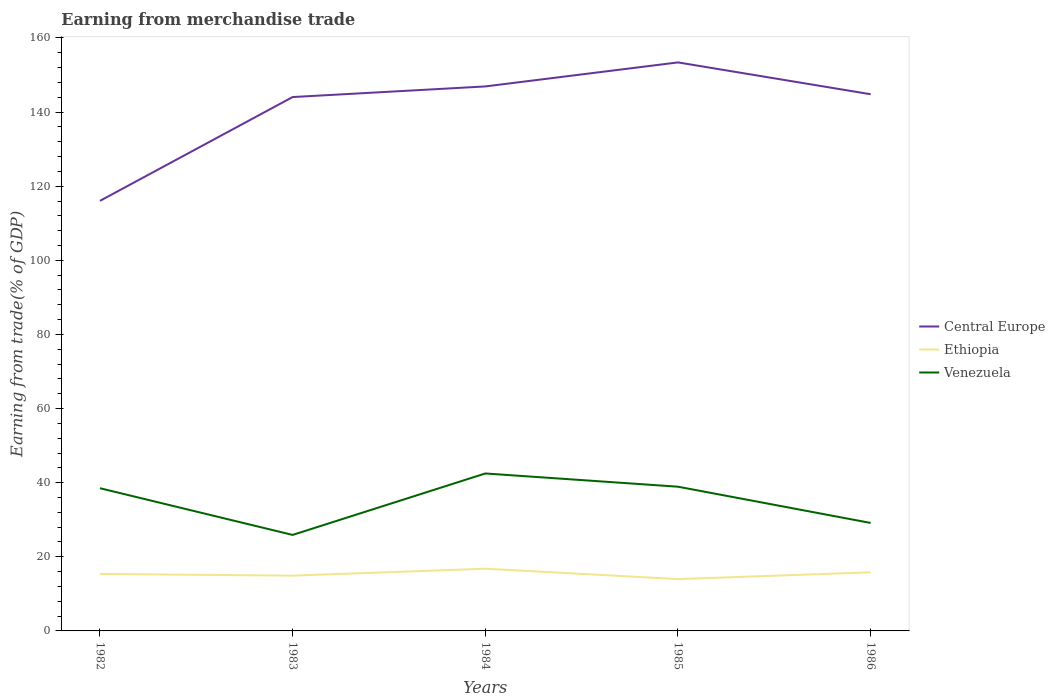How many different coloured lines are there?
Offer a terse response. 3. Does the line corresponding to Venezuela intersect with the line corresponding to Central Europe?
Make the answer very short. No. Is the number of lines equal to the number of legend labels?
Ensure brevity in your answer.  Yes. Across all years, what is the maximum earnings from trade in Central Europe?
Your answer should be very brief. 116.04. What is the total earnings from trade in Venezuela in the graph?
Offer a terse response. 3.57. What is the difference between the highest and the second highest earnings from trade in Venezuela?
Your response must be concise. 16.58. Is the earnings from trade in Ethiopia strictly greater than the earnings from trade in Central Europe over the years?
Give a very brief answer. Yes. Are the values on the major ticks of Y-axis written in scientific E-notation?
Your answer should be very brief. No. How many legend labels are there?
Keep it short and to the point. 3. What is the title of the graph?
Your answer should be compact. Earning from merchandise trade. What is the label or title of the Y-axis?
Give a very brief answer. Earning from trade(% of GDP). What is the Earning from trade(% of GDP) in Central Europe in 1982?
Make the answer very short. 116.04. What is the Earning from trade(% of GDP) in Ethiopia in 1982?
Offer a very short reply. 15.37. What is the Earning from trade(% of GDP) in Venezuela in 1982?
Provide a succinct answer. 38.51. What is the Earning from trade(% of GDP) of Central Europe in 1983?
Offer a terse response. 144.05. What is the Earning from trade(% of GDP) in Ethiopia in 1983?
Provide a short and direct response. 14.92. What is the Earning from trade(% of GDP) in Venezuela in 1983?
Offer a very short reply. 25.9. What is the Earning from trade(% of GDP) of Central Europe in 1984?
Keep it short and to the point. 146.92. What is the Earning from trade(% of GDP) in Ethiopia in 1984?
Your answer should be compact. 16.79. What is the Earning from trade(% of GDP) of Venezuela in 1984?
Give a very brief answer. 42.48. What is the Earning from trade(% of GDP) of Central Europe in 1985?
Ensure brevity in your answer.  153.4. What is the Earning from trade(% of GDP) of Ethiopia in 1985?
Ensure brevity in your answer.  13.99. What is the Earning from trade(% of GDP) in Venezuela in 1985?
Your answer should be very brief. 38.91. What is the Earning from trade(% of GDP) in Central Europe in 1986?
Your response must be concise. 144.81. What is the Earning from trade(% of GDP) in Ethiopia in 1986?
Your response must be concise. 15.81. What is the Earning from trade(% of GDP) in Venezuela in 1986?
Give a very brief answer. 29.13. Across all years, what is the maximum Earning from trade(% of GDP) in Central Europe?
Provide a succinct answer. 153.4. Across all years, what is the maximum Earning from trade(% of GDP) in Ethiopia?
Your answer should be compact. 16.79. Across all years, what is the maximum Earning from trade(% of GDP) of Venezuela?
Ensure brevity in your answer.  42.48. Across all years, what is the minimum Earning from trade(% of GDP) of Central Europe?
Make the answer very short. 116.04. Across all years, what is the minimum Earning from trade(% of GDP) in Ethiopia?
Your answer should be compact. 13.99. Across all years, what is the minimum Earning from trade(% of GDP) of Venezuela?
Make the answer very short. 25.9. What is the total Earning from trade(% of GDP) of Central Europe in the graph?
Offer a terse response. 705.21. What is the total Earning from trade(% of GDP) in Ethiopia in the graph?
Provide a short and direct response. 76.87. What is the total Earning from trade(% of GDP) in Venezuela in the graph?
Your answer should be very brief. 174.94. What is the difference between the Earning from trade(% of GDP) of Central Europe in 1982 and that in 1983?
Provide a succinct answer. -28.01. What is the difference between the Earning from trade(% of GDP) of Ethiopia in 1982 and that in 1983?
Give a very brief answer. 0.46. What is the difference between the Earning from trade(% of GDP) of Venezuela in 1982 and that in 1983?
Provide a succinct answer. 12.61. What is the difference between the Earning from trade(% of GDP) of Central Europe in 1982 and that in 1984?
Your answer should be very brief. -30.88. What is the difference between the Earning from trade(% of GDP) of Ethiopia in 1982 and that in 1984?
Offer a terse response. -1.41. What is the difference between the Earning from trade(% of GDP) in Venezuela in 1982 and that in 1984?
Provide a short and direct response. -3.98. What is the difference between the Earning from trade(% of GDP) in Central Europe in 1982 and that in 1985?
Ensure brevity in your answer.  -37.36. What is the difference between the Earning from trade(% of GDP) of Ethiopia in 1982 and that in 1985?
Offer a terse response. 1.39. What is the difference between the Earning from trade(% of GDP) of Venezuela in 1982 and that in 1985?
Offer a very short reply. -0.4. What is the difference between the Earning from trade(% of GDP) of Central Europe in 1982 and that in 1986?
Give a very brief answer. -28.77. What is the difference between the Earning from trade(% of GDP) of Ethiopia in 1982 and that in 1986?
Keep it short and to the point. -0.44. What is the difference between the Earning from trade(% of GDP) in Venezuela in 1982 and that in 1986?
Provide a succinct answer. 9.38. What is the difference between the Earning from trade(% of GDP) in Central Europe in 1983 and that in 1984?
Your answer should be compact. -2.87. What is the difference between the Earning from trade(% of GDP) of Ethiopia in 1983 and that in 1984?
Your answer should be very brief. -1.87. What is the difference between the Earning from trade(% of GDP) in Venezuela in 1983 and that in 1984?
Offer a terse response. -16.58. What is the difference between the Earning from trade(% of GDP) of Central Europe in 1983 and that in 1985?
Ensure brevity in your answer.  -9.35. What is the difference between the Earning from trade(% of GDP) of Ethiopia in 1983 and that in 1985?
Offer a terse response. 0.93. What is the difference between the Earning from trade(% of GDP) of Venezuela in 1983 and that in 1985?
Your answer should be compact. -13.01. What is the difference between the Earning from trade(% of GDP) of Central Europe in 1983 and that in 1986?
Provide a short and direct response. -0.76. What is the difference between the Earning from trade(% of GDP) in Ethiopia in 1983 and that in 1986?
Ensure brevity in your answer.  -0.89. What is the difference between the Earning from trade(% of GDP) in Venezuela in 1983 and that in 1986?
Ensure brevity in your answer.  -3.23. What is the difference between the Earning from trade(% of GDP) in Central Europe in 1984 and that in 1985?
Ensure brevity in your answer.  -6.48. What is the difference between the Earning from trade(% of GDP) of Ethiopia in 1984 and that in 1985?
Provide a short and direct response. 2.8. What is the difference between the Earning from trade(% of GDP) in Venezuela in 1984 and that in 1985?
Your answer should be compact. 3.57. What is the difference between the Earning from trade(% of GDP) of Central Europe in 1984 and that in 1986?
Give a very brief answer. 2.11. What is the difference between the Earning from trade(% of GDP) of Ethiopia in 1984 and that in 1986?
Your response must be concise. 0.98. What is the difference between the Earning from trade(% of GDP) of Venezuela in 1984 and that in 1986?
Offer a very short reply. 13.35. What is the difference between the Earning from trade(% of GDP) of Central Europe in 1985 and that in 1986?
Make the answer very short. 8.59. What is the difference between the Earning from trade(% of GDP) in Ethiopia in 1985 and that in 1986?
Provide a short and direct response. -1.82. What is the difference between the Earning from trade(% of GDP) of Venezuela in 1985 and that in 1986?
Your answer should be very brief. 9.78. What is the difference between the Earning from trade(% of GDP) of Central Europe in 1982 and the Earning from trade(% of GDP) of Ethiopia in 1983?
Ensure brevity in your answer.  101.12. What is the difference between the Earning from trade(% of GDP) in Central Europe in 1982 and the Earning from trade(% of GDP) in Venezuela in 1983?
Provide a succinct answer. 90.13. What is the difference between the Earning from trade(% of GDP) in Ethiopia in 1982 and the Earning from trade(% of GDP) in Venezuela in 1983?
Provide a succinct answer. -10.53. What is the difference between the Earning from trade(% of GDP) of Central Europe in 1982 and the Earning from trade(% of GDP) of Ethiopia in 1984?
Make the answer very short. 99.25. What is the difference between the Earning from trade(% of GDP) of Central Europe in 1982 and the Earning from trade(% of GDP) of Venezuela in 1984?
Make the answer very short. 73.55. What is the difference between the Earning from trade(% of GDP) in Ethiopia in 1982 and the Earning from trade(% of GDP) in Venezuela in 1984?
Provide a succinct answer. -27.11. What is the difference between the Earning from trade(% of GDP) in Central Europe in 1982 and the Earning from trade(% of GDP) in Ethiopia in 1985?
Provide a succinct answer. 102.05. What is the difference between the Earning from trade(% of GDP) in Central Europe in 1982 and the Earning from trade(% of GDP) in Venezuela in 1985?
Provide a short and direct response. 77.12. What is the difference between the Earning from trade(% of GDP) in Ethiopia in 1982 and the Earning from trade(% of GDP) in Venezuela in 1985?
Offer a very short reply. -23.54. What is the difference between the Earning from trade(% of GDP) of Central Europe in 1982 and the Earning from trade(% of GDP) of Ethiopia in 1986?
Give a very brief answer. 100.23. What is the difference between the Earning from trade(% of GDP) of Central Europe in 1982 and the Earning from trade(% of GDP) of Venezuela in 1986?
Provide a succinct answer. 86.9. What is the difference between the Earning from trade(% of GDP) in Ethiopia in 1982 and the Earning from trade(% of GDP) in Venezuela in 1986?
Offer a very short reply. -13.76. What is the difference between the Earning from trade(% of GDP) of Central Europe in 1983 and the Earning from trade(% of GDP) of Ethiopia in 1984?
Provide a short and direct response. 127.26. What is the difference between the Earning from trade(% of GDP) in Central Europe in 1983 and the Earning from trade(% of GDP) in Venezuela in 1984?
Provide a short and direct response. 101.57. What is the difference between the Earning from trade(% of GDP) in Ethiopia in 1983 and the Earning from trade(% of GDP) in Venezuela in 1984?
Your answer should be compact. -27.57. What is the difference between the Earning from trade(% of GDP) in Central Europe in 1983 and the Earning from trade(% of GDP) in Ethiopia in 1985?
Your response must be concise. 130.06. What is the difference between the Earning from trade(% of GDP) of Central Europe in 1983 and the Earning from trade(% of GDP) of Venezuela in 1985?
Provide a short and direct response. 105.14. What is the difference between the Earning from trade(% of GDP) of Ethiopia in 1983 and the Earning from trade(% of GDP) of Venezuela in 1985?
Provide a short and direct response. -24. What is the difference between the Earning from trade(% of GDP) of Central Europe in 1983 and the Earning from trade(% of GDP) of Ethiopia in 1986?
Offer a very short reply. 128.24. What is the difference between the Earning from trade(% of GDP) of Central Europe in 1983 and the Earning from trade(% of GDP) of Venezuela in 1986?
Provide a short and direct response. 114.92. What is the difference between the Earning from trade(% of GDP) of Ethiopia in 1983 and the Earning from trade(% of GDP) of Venezuela in 1986?
Your answer should be compact. -14.22. What is the difference between the Earning from trade(% of GDP) of Central Europe in 1984 and the Earning from trade(% of GDP) of Ethiopia in 1985?
Ensure brevity in your answer.  132.93. What is the difference between the Earning from trade(% of GDP) of Central Europe in 1984 and the Earning from trade(% of GDP) of Venezuela in 1985?
Give a very brief answer. 108.01. What is the difference between the Earning from trade(% of GDP) in Ethiopia in 1984 and the Earning from trade(% of GDP) in Venezuela in 1985?
Your answer should be very brief. -22.13. What is the difference between the Earning from trade(% of GDP) of Central Europe in 1984 and the Earning from trade(% of GDP) of Ethiopia in 1986?
Your answer should be compact. 131.11. What is the difference between the Earning from trade(% of GDP) in Central Europe in 1984 and the Earning from trade(% of GDP) in Venezuela in 1986?
Keep it short and to the point. 117.78. What is the difference between the Earning from trade(% of GDP) of Ethiopia in 1984 and the Earning from trade(% of GDP) of Venezuela in 1986?
Provide a short and direct response. -12.35. What is the difference between the Earning from trade(% of GDP) of Central Europe in 1985 and the Earning from trade(% of GDP) of Ethiopia in 1986?
Your response must be concise. 137.59. What is the difference between the Earning from trade(% of GDP) in Central Europe in 1985 and the Earning from trade(% of GDP) in Venezuela in 1986?
Your answer should be compact. 124.26. What is the difference between the Earning from trade(% of GDP) of Ethiopia in 1985 and the Earning from trade(% of GDP) of Venezuela in 1986?
Give a very brief answer. -15.15. What is the average Earning from trade(% of GDP) of Central Europe per year?
Provide a succinct answer. 141.04. What is the average Earning from trade(% of GDP) in Ethiopia per year?
Your answer should be compact. 15.37. What is the average Earning from trade(% of GDP) in Venezuela per year?
Your answer should be very brief. 34.99. In the year 1982, what is the difference between the Earning from trade(% of GDP) of Central Europe and Earning from trade(% of GDP) of Ethiopia?
Offer a terse response. 100.66. In the year 1982, what is the difference between the Earning from trade(% of GDP) of Central Europe and Earning from trade(% of GDP) of Venezuela?
Your response must be concise. 77.53. In the year 1982, what is the difference between the Earning from trade(% of GDP) in Ethiopia and Earning from trade(% of GDP) in Venezuela?
Ensure brevity in your answer.  -23.13. In the year 1983, what is the difference between the Earning from trade(% of GDP) of Central Europe and Earning from trade(% of GDP) of Ethiopia?
Your answer should be compact. 129.13. In the year 1983, what is the difference between the Earning from trade(% of GDP) in Central Europe and Earning from trade(% of GDP) in Venezuela?
Offer a very short reply. 118.15. In the year 1983, what is the difference between the Earning from trade(% of GDP) of Ethiopia and Earning from trade(% of GDP) of Venezuela?
Offer a very short reply. -10.99. In the year 1984, what is the difference between the Earning from trade(% of GDP) of Central Europe and Earning from trade(% of GDP) of Ethiopia?
Provide a short and direct response. 130.13. In the year 1984, what is the difference between the Earning from trade(% of GDP) of Central Europe and Earning from trade(% of GDP) of Venezuela?
Your answer should be compact. 104.43. In the year 1984, what is the difference between the Earning from trade(% of GDP) in Ethiopia and Earning from trade(% of GDP) in Venezuela?
Provide a short and direct response. -25.7. In the year 1985, what is the difference between the Earning from trade(% of GDP) of Central Europe and Earning from trade(% of GDP) of Ethiopia?
Ensure brevity in your answer.  139.41. In the year 1985, what is the difference between the Earning from trade(% of GDP) in Central Europe and Earning from trade(% of GDP) in Venezuela?
Your answer should be very brief. 114.49. In the year 1985, what is the difference between the Earning from trade(% of GDP) in Ethiopia and Earning from trade(% of GDP) in Venezuela?
Your response must be concise. -24.93. In the year 1986, what is the difference between the Earning from trade(% of GDP) of Central Europe and Earning from trade(% of GDP) of Ethiopia?
Keep it short and to the point. 129. In the year 1986, what is the difference between the Earning from trade(% of GDP) in Central Europe and Earning from trade(% of GDP) in Venezuela?
Make the answer very short. 115.68. In the year 1986, what is the difference between the Earning from trade(% of GDP) of Ethiopia and Earning from trade(% of GDP) of Venezuela?
Your answer should be compact. -13.32. What is the ratio of the Earning from trade(% of GDP) in Central Europe in 1982 to that in 1983?
Your answer should be compact. 0.81. What is the ratio of the Earning from trade(% of GDP) in Ethiopia in 1982 to that in 1983?
Provide a short and direct response. 1.03. What is the ratio of the Earning from trade(% of GDP) in Venezuela in 1982 to that in 1983?
Keep it short and to the point. 1.49. What is the ratio of the Earning from trade(% of GDP) of Central Europe in 1982 to that in 1984?
Your answer should be compact. 0.79. What is the ratio of the Earning from trade(% of GDP) of Ethiopia in 1982 to that in 1984?
Offer a terse response. 0.92. What is the ratio of the Earning from trade(% of GDP) in Venezuela in 1982 to that in 1984?
Your answer should be compact. 0.91. What is the ratio of the Earning from trade(% of GDP) of Central Europe in 1982 to that in 1985?
Provide a short and direct response. 0.76. What is the ratio of the Earning from trade(% of GDP) of Ethiopia in 1982 to that in 1985?
Make the answer very short. 1.1. What is the ratio of the Earning from trade(% of GDP) of Central Europe in 1982 to that in 1986?
Your answer should be very brief. 0.8. What is the ratio of the Earning from trade(% of GDP) in Ethiopia in 1982 to that in 1986?
Offer a terse response. 0.97. What is the ratio of the Earning from trade(% of GDP) in Venezuela in 1982 to that in 1986?
Your answer should be compact. 1.32. What is the ratio of the Earning from trade(% of GDP) of Central Europe in 1983 to that in 1984?
Keep it short and to the point. 0.98. What is the ratio of the Earning from trade(% of GDP) in Ethiopia in 1983 to that in 1984?
Offer a very short reply. 0.89. What is the ratio of the Earning from trade(% of GDP) in Venezuela in 1983 to that in 1984?
Provide a short and direct response. 0.61. What is the ratio of the Earning from trade(% of GDP) in Central Europe in 1983 to that in 1985?
Keep it short and to the point. 0.94. What is the ratio of the Earning from trade(% of GDP) of Ethiopia in 1983 to that in 1985?
Provide a short and direct response. 1.07. What is the ratio of the Earning from trade(% of GDP) of Venezuela in 1983 to that in 1985?
Your answer should be compact. 0.67. What is the ratio of the Earning from trade(% of GDP) in Ethiopia in 1983 to that in 1986?
Your response must be concise. 0.94. What is the ratio of the Earning from trade(% of GDP) in Venezuela in 1983 to that in 1986?
Keep it short and to the point. 0.89. What is the ratio of the Earning from trade(% of GDP) of Central Europe in 1984 to that in 1985?
Offer a terse response. 0.96. What is the ratio of the Earning from trade(% of GDP) of Ethiopia in 1984 to that in 1985?
Provide a short and direct response. 1.2. What is the ratio of the Earning from trade(% of GDP) in Venezuela in 1984 to that in 1985?
Your answer should be compact. 1.09. What is the ratio of the Earning from trade(% of GDP) in Central Europe in 1984 to that in 1986?
Provide a short and direct response. 1.01. What is the ratio of the Earning from trade(% of GDP) of Ethiopia in 1984 to that in 1986?
Give a very brief answer. 1.06. What is the ratio of the Earning from trade(% of GDP) of Venezuela in 1984 to that in 1986?
Ensure brevity in your answer.  1.46. What is the ratio of the Earning from trade(% of GDP) in Central Europe in 1985 to that in 1986?
Your answer should be very brief. 1.06. What is the ratio of the Earning from trade(% of GDP) in Ethiopia in 1985 to that in 1986?
Give a very brief answer. 0.88. What is the ratio of the Earning from trade(% of GDP) of Venezuela in 1985 to that in 1986?
Your response must be concise. 1.34. What is the difference between the highest and the second highest Earning from trade(% of GDP) of Central Europe?
Your response must be concise. 6.48. What is the difference between the highest and the second highest Earning from trade(% of GDP) of Ethiopia?
Offer a terse response. 0.98. What is the difference between the highest and the second highest Earning from trade(% of GDP) in Venezuela?
Make the answer very short. 3.57. What is the difference between the highest and the lowest Earning from trade(% of GDP) in Central Europe?
Provide a succinct answer. 37.36. What is the difference between the highest and the lowest Earning from trade(% of GDP) of Ethiopia?
Offer a terse response. 2.8. What is the difference between the highest and the lowest Earning from trade(% of GDP) of Venezuela?
Keep it short and to the point. 16.58. 